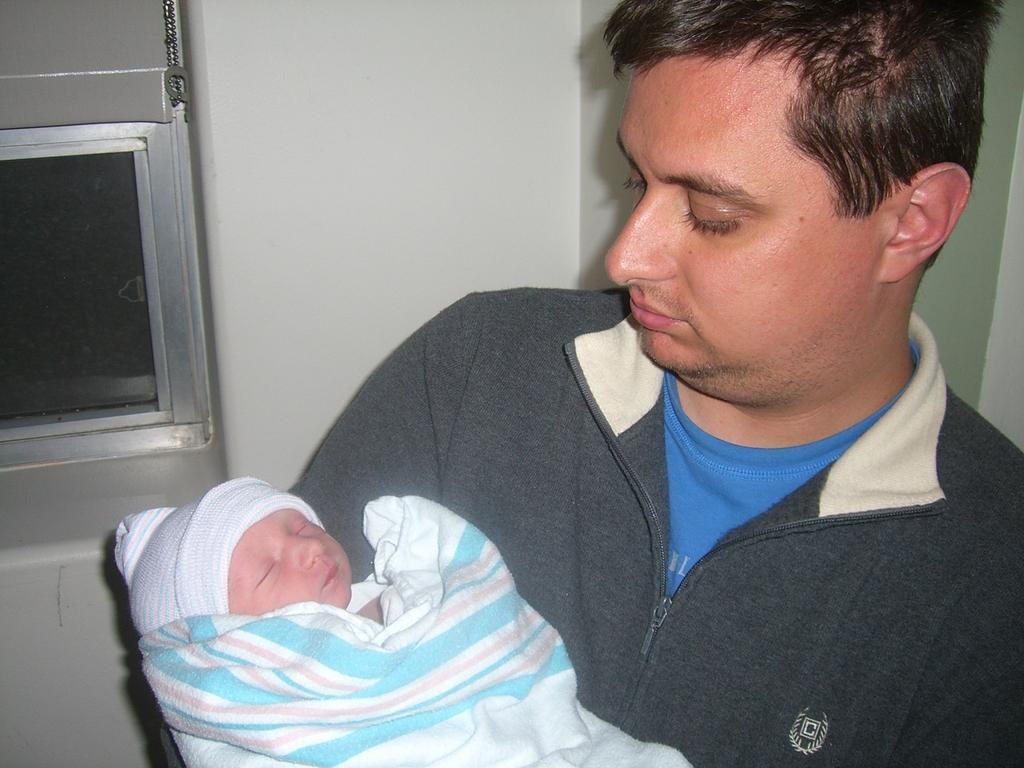Please provide a concise description of this image. In this image there is a metal object in the left corner. There is a person carrying a kid in the foreground. And there is a wall in the background. 